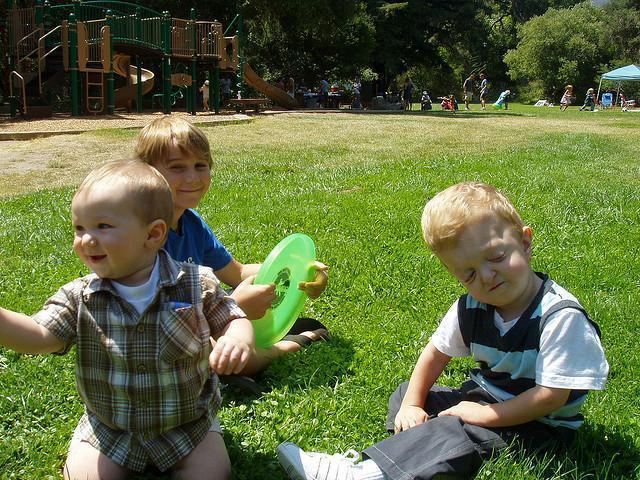How many children are in this picture?
Give a very brief answer. 3. How many people are in the picture?
Give a very brief answer. 4. 